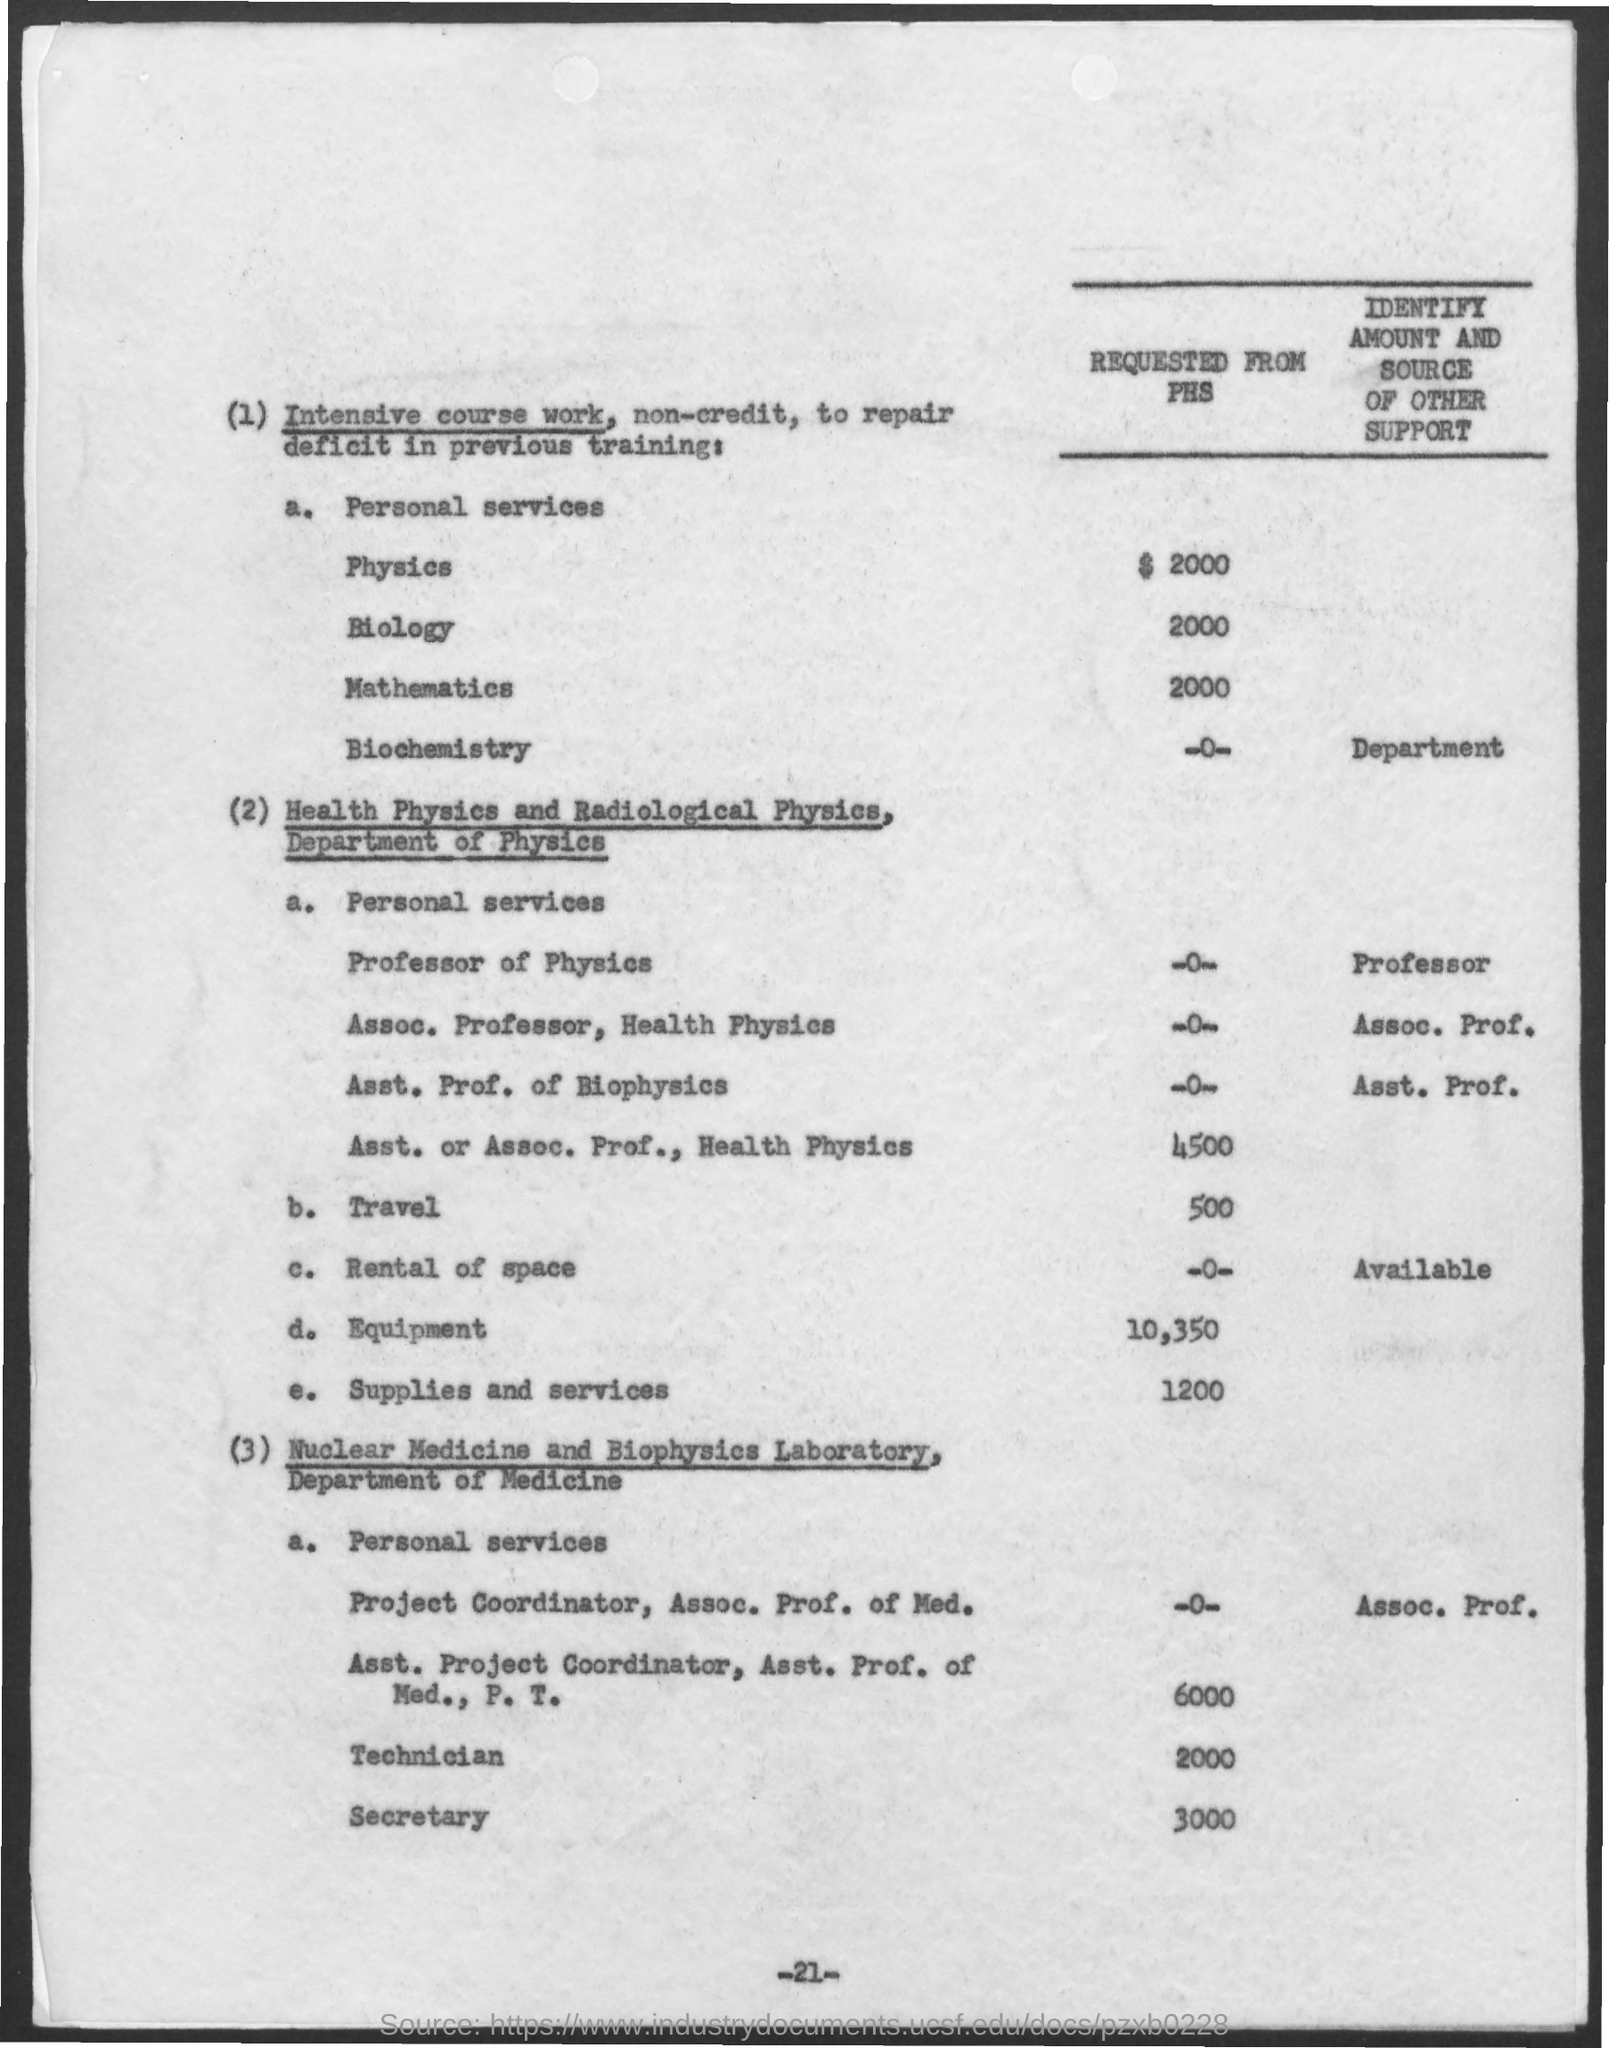Indicate a few pertinent items in this graphic. The amount requested from PHS for mathematics is 2000. The amount requested from PHS for travel is 500. The amount requested from PHS for supplies and services is 1200. The amount requested from PHS for the secretary is 3000. The amount requested from PHS for a technician is 2000. 